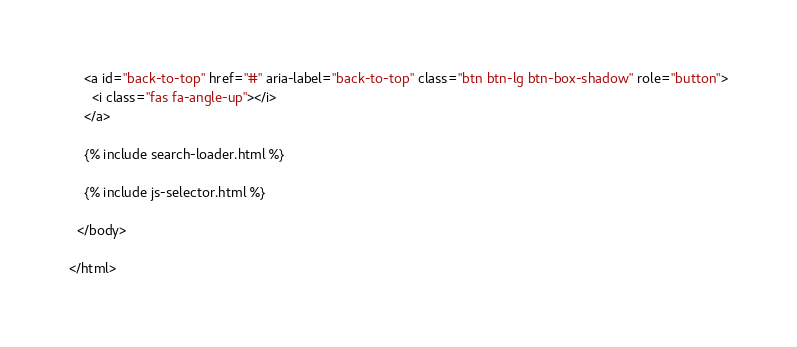<code> <loc_0><loc_0><loc_500><loc_500><_HTML_>
    <a id="back-to-top" href="#" aria-label="back-to-top" class="btn btn-lg btn-box-shadow" role="button">
      <i class="fas fa-angle-up"></i>
    </a>

    {% include search-loader.html %}

    {% include js-selector.html %}

  </body>

</html>
</code> 